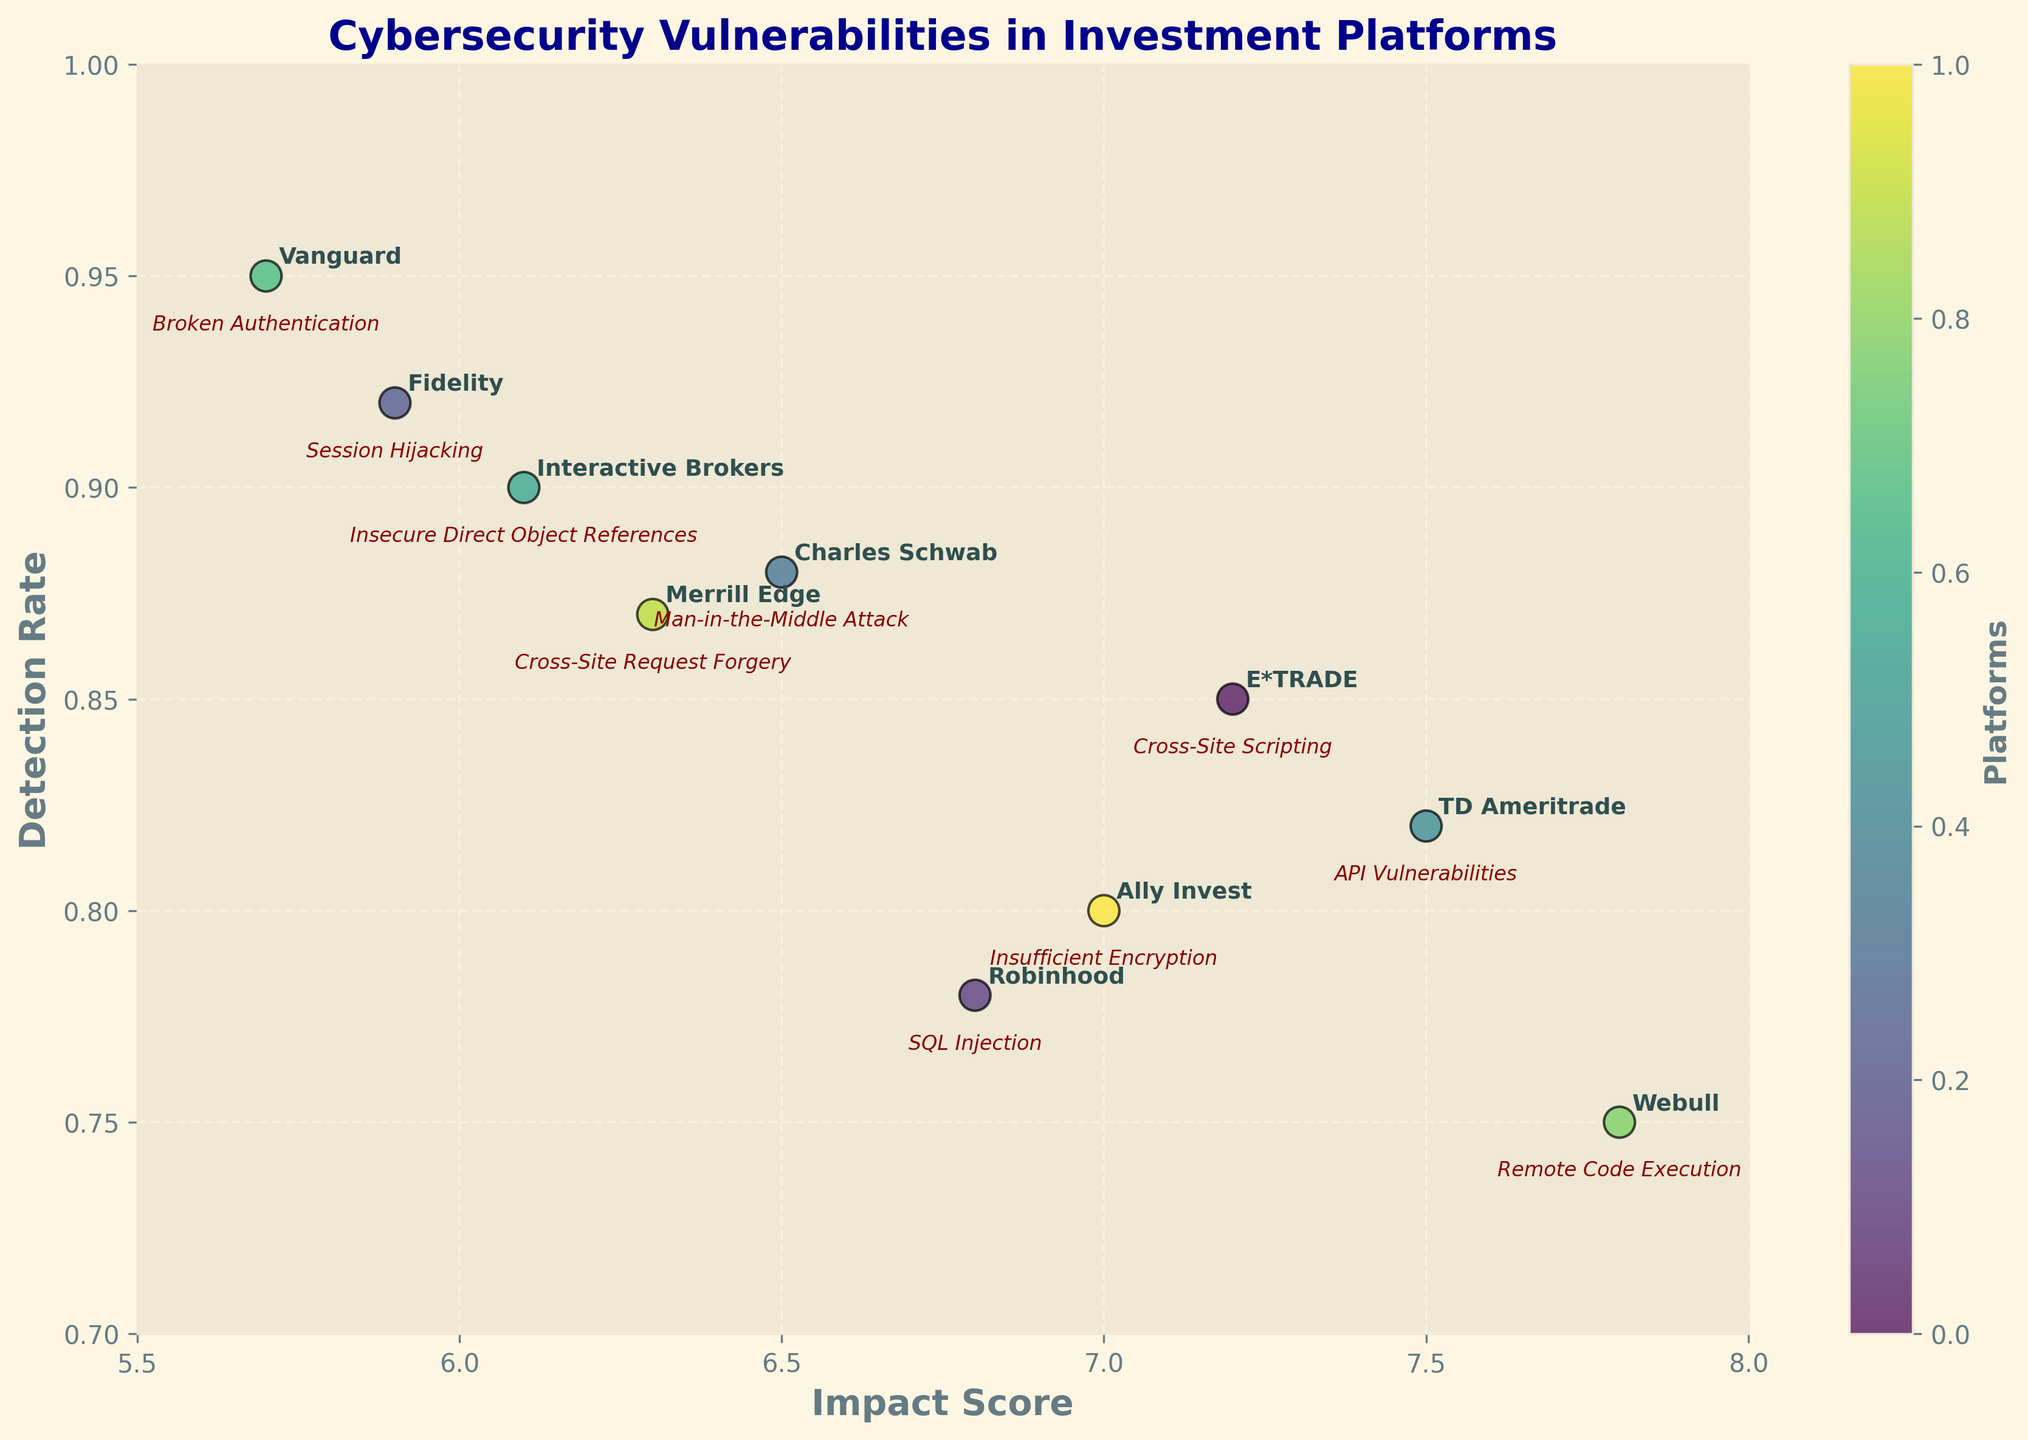How many platforms are plotted in the figure? Count the number of distinct data points annotated with platform names.
Answer: 10 What is the title of the plot? Read the title text displayed at the top of the plot.
Answer: Cybersecurity Vulnerabilities in Investment Platforms Which platform has the highest impact score? Identify the data point with the maximum value on the x-axis and refer to its annotation for the platform name.
Answer: Webull Which platform has the highest detection rate? Identify the data point with the maximum value on the y-axis and refer to its annotation for the platform name.
Answer: Vanguard What is the impact score and detection rate for Charles Schwab? Locate the annotation for Charles Schwab on the plot and check its x and y coordinates.
Answer: Impact Score: 6.5, Detection Rate: 0.88 What is the detection rate difference between Webull and Robinhood? Find the y-values for Webull and Robinhood, then calculate the difference (0.75 - 0.78).
Answer: -0.03 Which platform has the lowest detection rate? Identify the data point with the minimum value on the y-axis and refer to its annotation for the platform name.
Answer: Webull How do the detection rates of Fidelity and Interactive Brokers compare? Locate the y-values for Fidelity and Interactive Brokers and compare them.
Answer: Fidelity has a higher detection rate than Interactive Brokers What is the relationship between impact score and detection rate in the plot? Observe the overall trend of data point placements to describe their relationship.
Answer: There is no clear trend, both high and low impact scores have varying detection rates What are the vulnerability types for the highest and lowest impact score platforms? Identify the platforms with the highest and lowest impact scores and read their vulnerability types from the plot annotations.
Answer: Remote Code Execution for Webull; Broken Authentication for Vanguard 